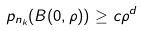<formula> <loc_0><loc_0><loc_500><loc_500>p _ { n _ { k } } ( B ( 0 , \rho ) ) \geq c { \rho ^ { d } }</formula> 